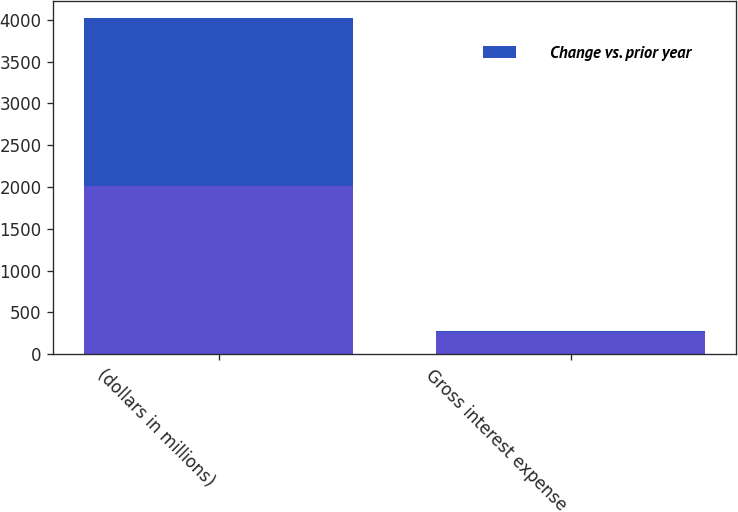<chart> <loc_0><loc_0><loc_500><loc_500><stacked_bar_chart><ecel><fcel>(dollars in millions)<fcel>Gross interest expense<nl><fcel>nan<fcel>2012<fcel>263<nl><fcel>Change vs. prior year<fcel>2012<fcel>10.5<nl></chart> 